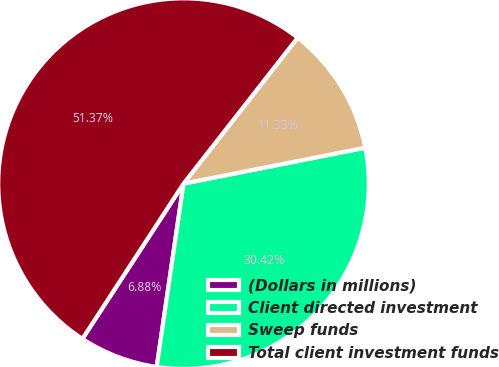<chart> <loc_0><loc_0><loc_500><loc_500><pie_chart><fcel>(Dollars in millions)<fcel>Client directed investment<fcel>Sweep funds<fcel>Total client investment funds<nl><fcel>6.88%<fcel>30.42%<fcel>11.33%<fcel>51.37%<nl></chart> 